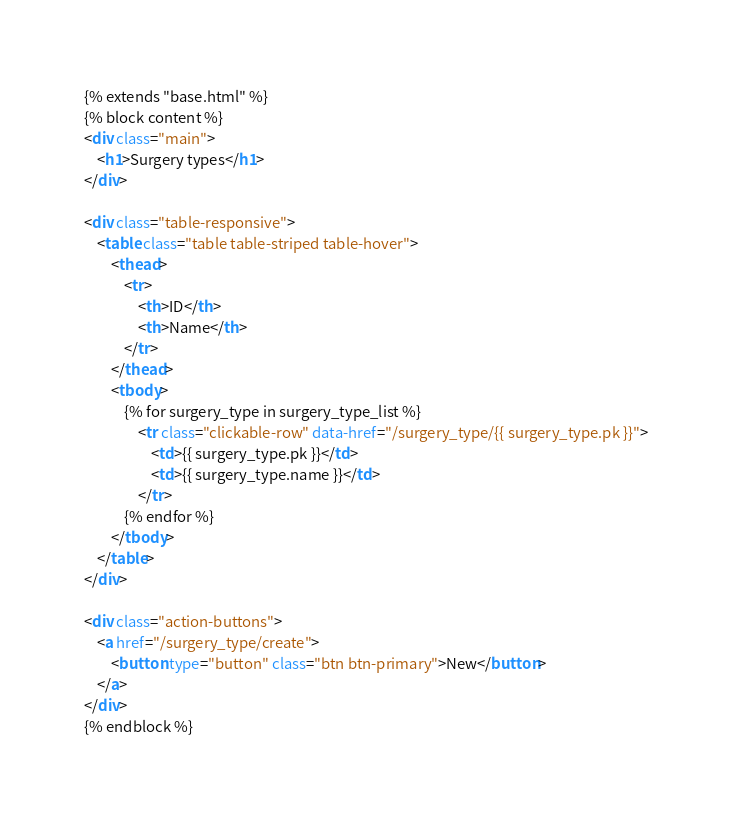<code> <loc_0><loc_0><loc_500><loc_500><_HTML_>{% extends "base.html" %}
{% block content %}
<div class="main">
    <h1>Surgery types</h1>
</div>

<div class="table-responsive">
    <table class="table table-striped table-hover">
        <thead>
            <tr>
                <th>ID</th>
                <th>Name</th>
            </tr>
        </thead>
        <tbody>
            {% for surgery_type in surgery_type_list %}
                <tr class="clickable-row" data-href="/surgery_type/{{ surgery_type.pk }}">
                    <td>{{ surgery_type.pk }}</td>
                    <td>{{ surgery_type.name }}</td>
                </tr>
            {% endfor %}
        </tbody>
    </table>
</div>

<div class="action-buttons">
    <a href="/surgery_type/create">
        <button type="button" class="btn btn-primary">New</button>
    </a>
</div>
{% endblock %}</code> 